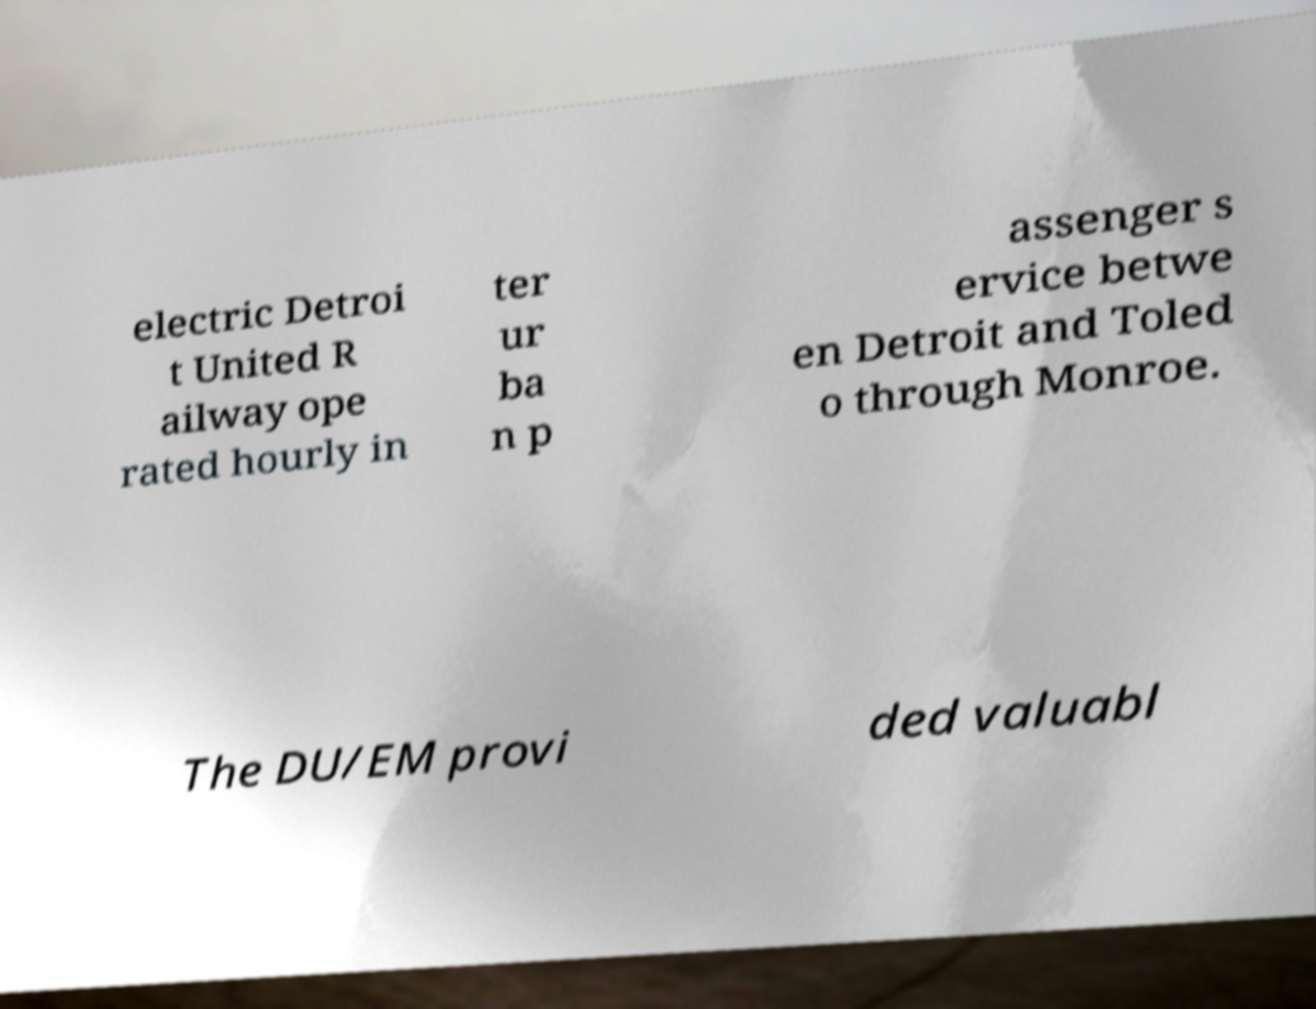Can you read and provide the text displayed in the image?This photo seems to have some interesting text. Can you extract and type it out for me? electric Detroi t United R ailway ope rated hourly in ter ur ba n p assenger s ervice betwe en Detroit and Toled o through Monroe. The DU/EM provi ded valuabl 